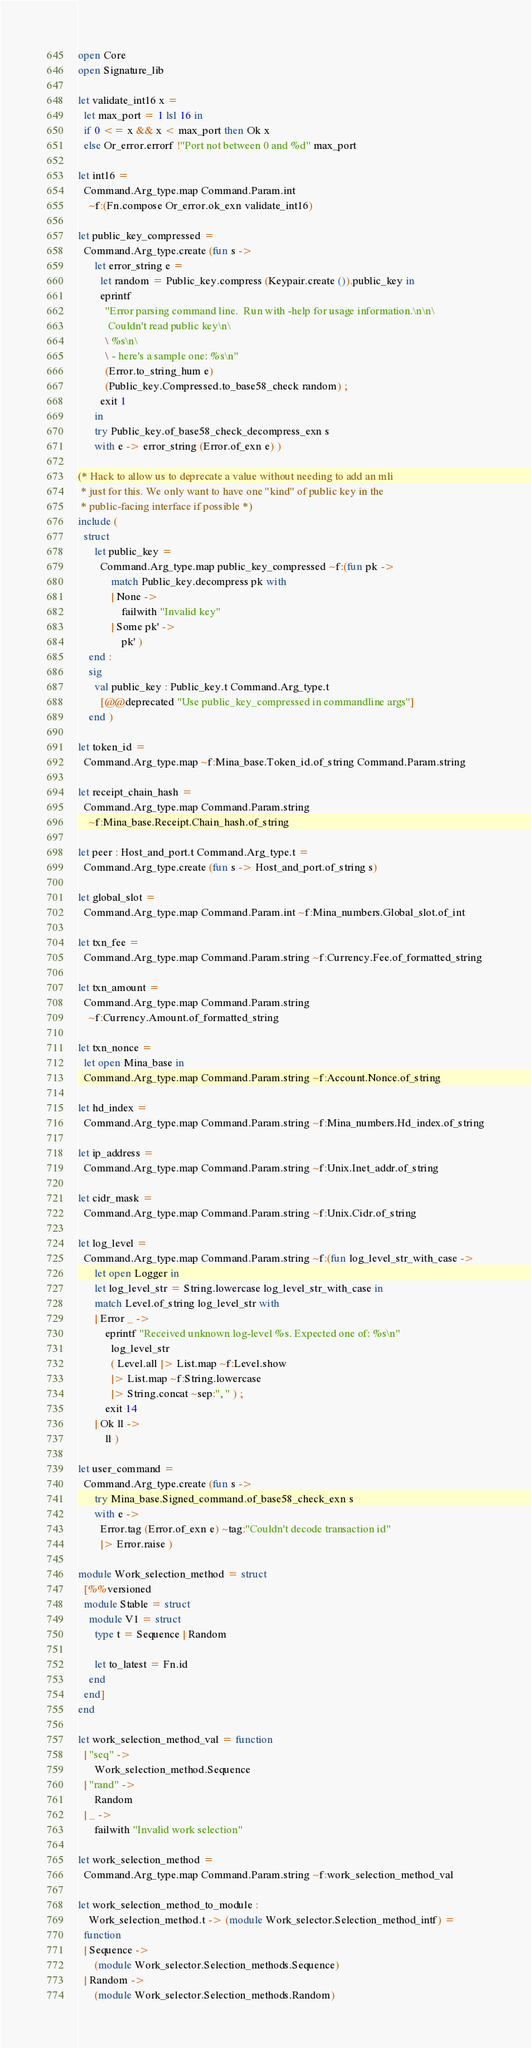<code> <loc_0><loc_0><loc_500><loc_500><_OCaml_>open Core
open Signature_lib

let validate_int16 x =
  let max_port = 1 lsl 16 in
  if 0 <= x && x < max_port then Ok x
  else Or_error.errorf !"Port not between 0 and %d" max_port

let int16 =
  Command.Arg_type.map Command.Param.int
    ~f:(Fn.compose Or_error.ok_exn validate_int16)

let public_key_compressed =
  Command.Arg_type.create (fun s ->
      let error_string e =
        let random = Public_key.compress (Keypair.create ()).public_key in
        eprintf
          "Error parsing command line.  Run with -help for usage information.\n\n\
           Couldn't read public key\n\
          \ %s\n\
          \ - here's a sample one: %s\n"
          (Error.to_string_hum e)
          (Public_key.Compressed.to_base58_check random) ;
        exit 1
      in
      try Public_key.of_base58_check_decompress_exn s
      with e -> error_string (Error.of_exn e) )

(* Hack to allow us to deprecate a value without needing to add an mli
 * just for this. We only want to have one "kind" of public key in the
 * public-facing interface if possible *)
include (
  struct
      let public_key =
        Command.Arg_type.map public_key_compressed ~f:(fun pk ->
            match Public_key.decompress pk with
            | None ->
                failwith "Invalid key"
            | Some pk' ->
                pk' )
    end :
    sig
      val public_key : Public_key.t Command.Arg_type.t
        [@@deprecated "Use public_key_compressed in commandline args"]
    end )

let token_id =
  Command.Arg_type.map ~f:Mina_base.Token_id.of_string Command.Param.string

let receipt_chain_hash =
  Command.Arg_type.map Command.Param.string
    ~f:Mina_base.Receipt.Chain_hash.of_string

let peer : Host_and_port.t Command.Arg_type.t =
  Command.Arg_type.create (fun s -> Host_and_port.of_string s)

let global_slot =
  Command.Arg_type.map Command.Param.int ~f:Mina_numbers.Global_slot.of_int

let txn_fee =
  Command.Arg_type.map Command.Param.string ~f:Currency.Fee.of_formatted_string

let txn_amount =
  Command.Arg_type.map Command.Param.string
    ~f:Currency.Amount.of_formatted_string

let txn_nonce =
  let open Mina_base in
  Command.Arg_type.map Command.Param.string ~f:Account.Nonce.of_string

let hd_index =
  Command.Arg_type.map Command.Param.string ~f:Mina_numbers.Hd_index.of_string

let ip_address =
  Command.Arg_type.map Command.Param.string ~f:Unix.Inet_addr.of_string

let cidr_mask =
  Command.Arg_type.map Command.Param.string ~f:Unix.Cidr.of_string

let log_level =
  Command.Arg_type.map Command.Param.string ~f:(fun log_level_str_with_case ->
      let open Logger in
      let log_level_str = String.lowercase log_level_str_with_case in
      match Level.of_string log_level_str with
      | Error _ ->
          eprintf "Received unknown log-level %s. Expected one of: %s\n"
            log_level_str
            ( Level.all |> List.map ~f:Level.show
            |> List.map ~f:String.lowercase
            |> String.concat ~sep:", " ) ;
          exit 14
      | Ok ll ->
          ll )

let user_command =
  Command.Arg_type.create (fun s ->
      try Mina_base.Signed_command.of_base58_check_exn s
      with e ->
        Error.tag (Error.of_exn e) ~tag:"Couldn't decode transaction id"
        |> Error.raise )

module Work_selection_method = struct
  [%%versioned
  module Stable = struct
    module V1 = struct
      type t = Sequence | Random

      let to_latest = Fn.id
    end
  end]
end

let work_selection_method_val = function
  | "seq" ->
      Work_selection_method.Sequence
  | "rand" ->
      Random
  | _ ->
      failwith "Invalid work selection"

let work_selection_method =
  Command.Arg_type.map Command.Param.string ~f:work_selection_method_val

let work_selection_method_to_module :
    Work_selection_method.t -> (module Work_selector.Selection_method_intf) =
  function
  | Sequence ->
      (module Work_selector.Selection_methods.Sequence)
  | Random ->
      (module Work_selector.Selection_methods.Random)
</code> 